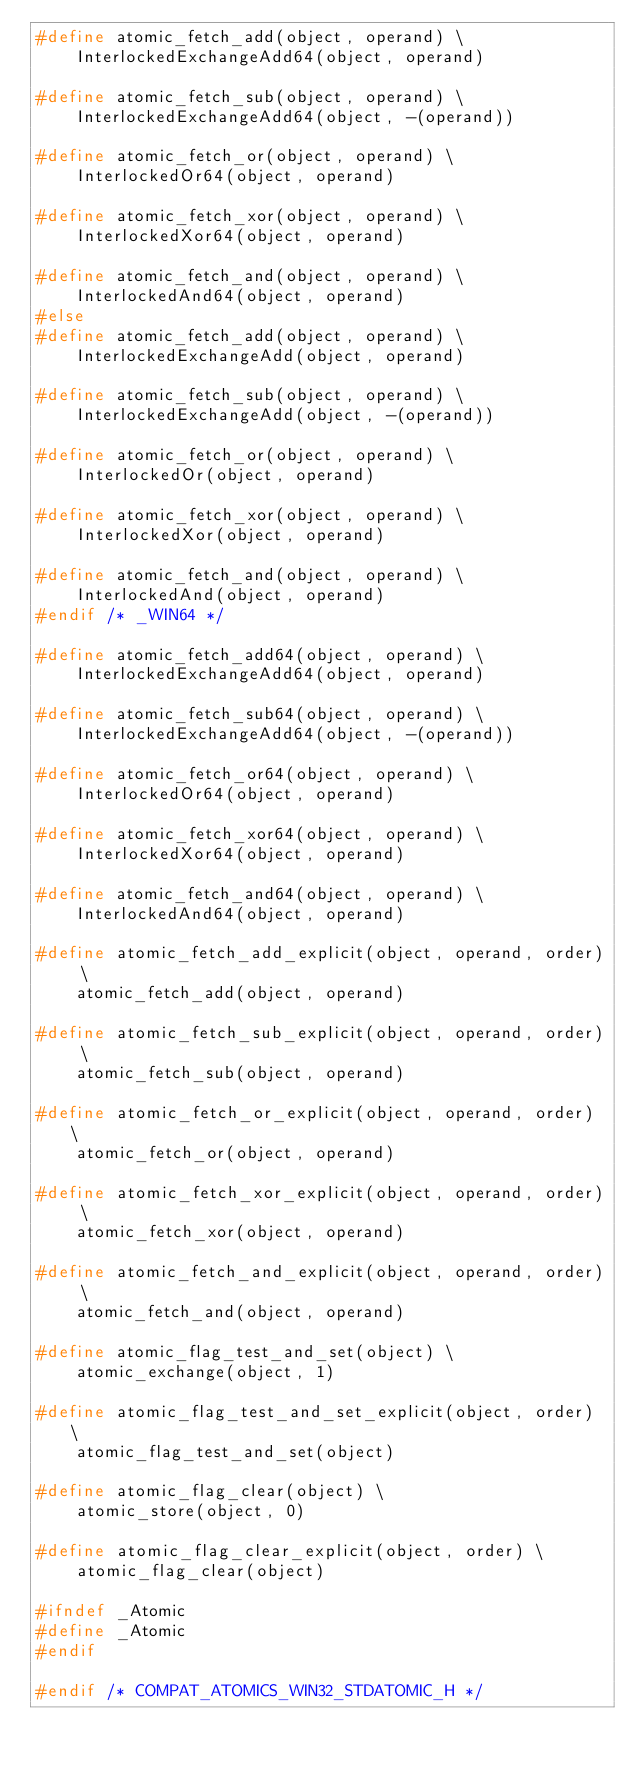Convert code to text. <code><loc_0><loc_0><loc_500><loc_500><_C_>#define atomic_fetch_add(object, operand) \
    InterlockedExchangeAdd64(object, operand)

#define atomic_fetch_sub(object, operand) \
    InterlockedExchangeAdd64(object, -(operand))

#define atomic_fetch_or(object, operand) \
    InterlockedOr64(object, operand)

#define atomic_fetch_xor(object, operand) \
    InterlockedXor64(object, operand)

#define atomic_fetch_and(object, operand) \
    InterlockedAnd64(object, operand)
#else
#define atomic_fetch_add(object, operand) \
    InterlockedExchangeAdd(object, operand)

#define atomic_fetch_sub(object, operand) \
    InterlockedExchangeAdd(object, -(operand))

#define atomic_fetch_or(object, operand) \
    InterlockedOr(object, operand)

#define atomic_fetch_xor(object, operand) \
    InterlockedXor(object, operand)

#define atomic_fetch_and(object, operand) \
    InterlockedAnd(object, operand)
#endif /* _WIN64 */

#define atomic_fetch_add64(object, operand) \
    InterlockedExchangeAdd64(object, operand)

#define atomic_fetch_sub64(object, operand) \
    InterlockedExchangeAdd64(object, -(operand))

#define atomic_fetch_or64(object, operand) \
    InterlockedOr64(object, operand)

#define atomic_fetch_xor64(object, operand) \
    InterlockedXor64(object, operand)

#define atomic_fetch_and64(object, operand) \
    InterlockedAnd64(object, operand)

#define atomic_fetch_add_explicit(object, operand, order) \
    atomic_fetch_add(object, operand)

#define atomic_fetch_sub_explicit(object, operand, order) \
    atomic_fetch_sub(object, operand)

#define atomic_fetch_or_explicit(object, operand, order) \
    atomic_fetch_or(object, operand)

#define atomic_fetch_xor_explicit(object, operand, order) \
    atomic_fetch_xor(object, operand)

#define atomic_fetch_and_explicit(object, operand, order) \
    atomic_fetch_and(object, operand)

#define atomic_flag_test_and_set(object) \
    atomic_exchange(object, 1)

#define atomic_flag_test_and_set_explicit(object, order) \
    atomic_flag_test_and_set(object)

#define atomic_flag_clear(object) \
    atomic_store(object, 0)

#define atomic_flag_clear_explicit(object, order) \
    atomic_flag_clear(object)
	
#ifndef _Atomic
#define _Atomic
#endif

#endif /* COMPAT_ATOMICS_WIN32_STDATOMIC_H */
</code> 